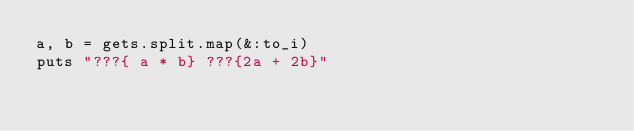<code> <loc_0><loc_0><loc_500><loc_500><_Ruby_>a, b = gets.split.map(&:to_i)
puts "???{ a * b} ???{2a + 2b}"</code> 